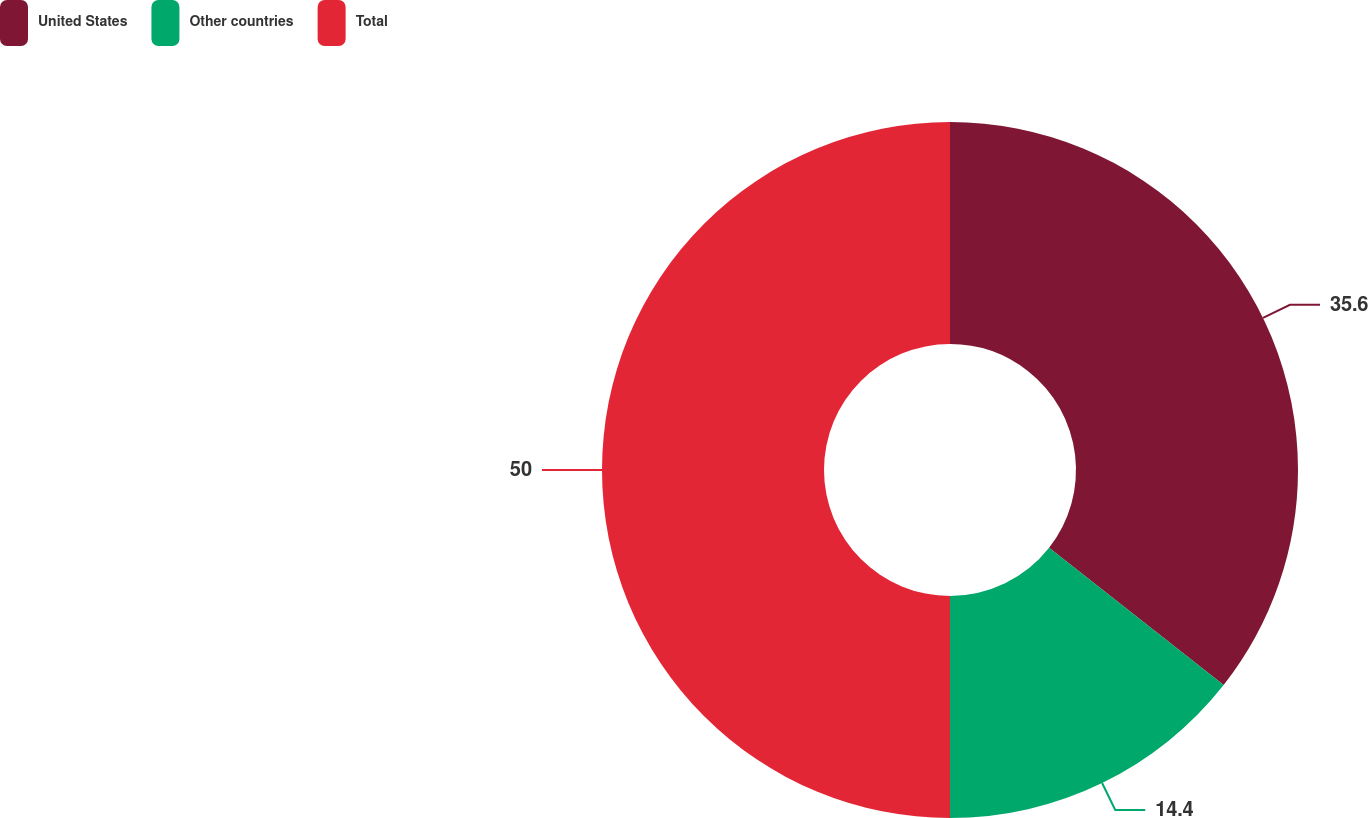<chart> <loc_0><loc_0><loc_500><loc_500><pie_chart><fcel>United States<fcel>Other countries<fcel>Total<nl><fcel>35.6%<fcel>14.4%<fcel>50.0%<nl></chart> 